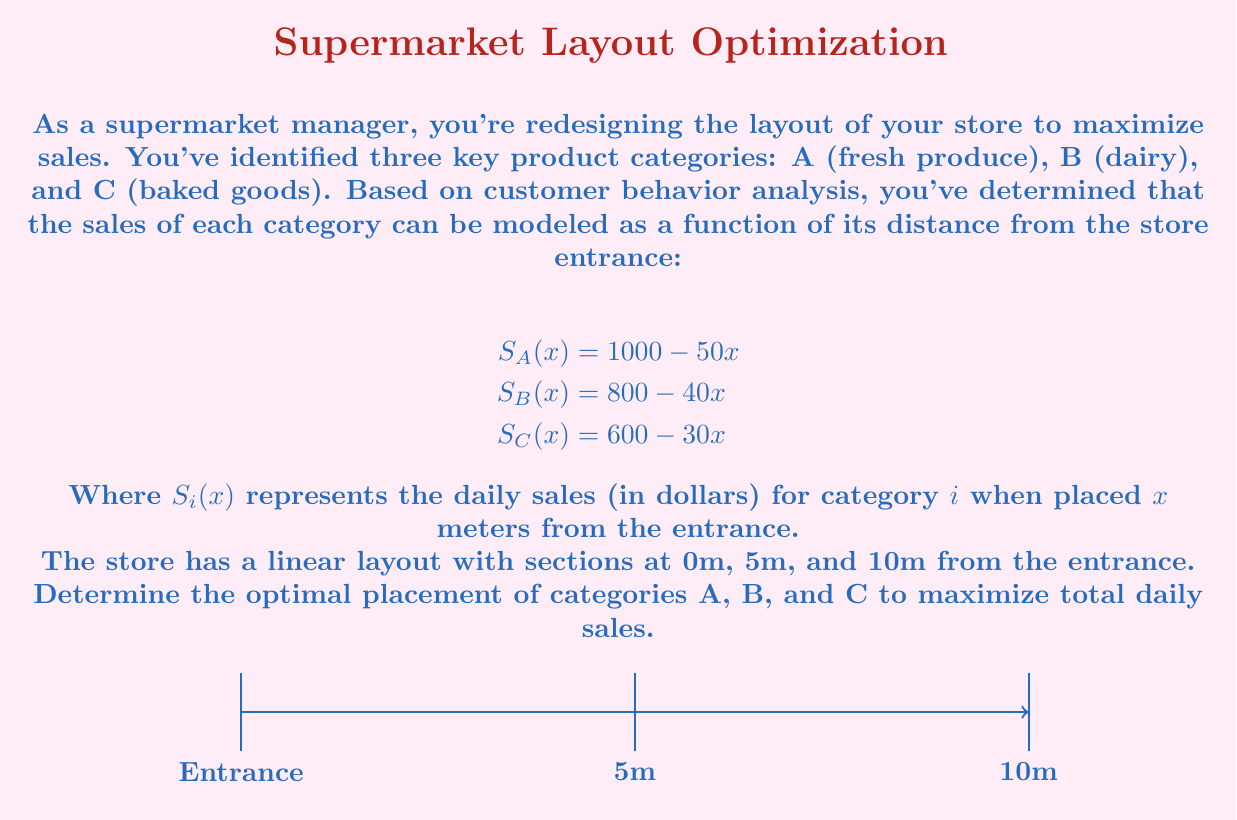Show me your answer to this math problem. To solve this problem, we need to consider all possible arrangements of the three categories and calculate the total sales for each:

1) First, let's calculate the sales for each category at each position:
   At 0m: $S_A(0) = 1000$, $S_B(0) = 800$, $S_C(0) = 600$
   At 5m: $S_A(5) = 750$, $S_B(5) = 600$, $S_C(5) = 450$
   At 10m: $S_A(10) = 500$, $S_B(10) = 400$, $S_C(10) = 300$

2) Now, let's calculate the total sales for each possible arrangement:

   ABC: $1000 + 600 + 300 = 1900$
   ACB: $1000 + 450 + 400 = 1850$
   BAC: $800 + 750 + 300 = 1850$
   BCA: $800 + 600 + 500 = 1900$
   CAB: $600 + 750 + 400 = 1750$
   CBA: $600 + 600 + 500 = 1700$

3) From these calculations, we can see that there are two arrangements that yield the maximum total sales of $1900: ABC and BCA.

4) However, as a community-oriented manager, you might prefer the ABC arrangement as it places fresh produce (category A) closest to the entrance, promoting healthier choices for families and children.
Answer: ABC or BCA, with ABC preferred for community health reasons. 